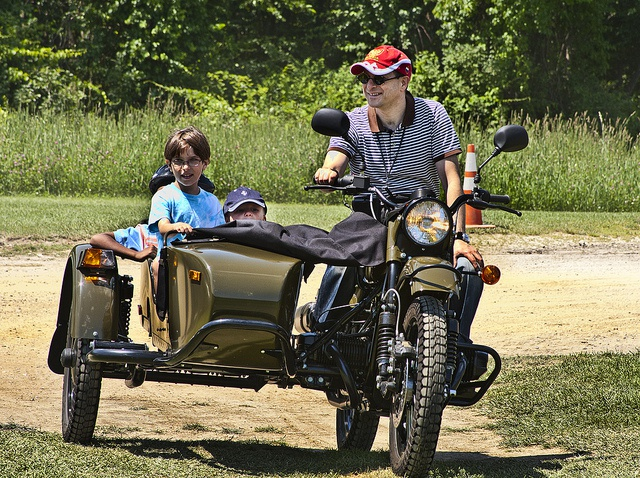Describe the objects in this image and their specific colors. I can see motorcycle in black, gray, darkgray, and tan tones, people in black, gray, lightgray, and darkgray tones, people in black, lightgray, lightblue, and gray tones, people in black, white, tan, and lightblue tones, and people in black, gray, and darkgray tones in this image. 